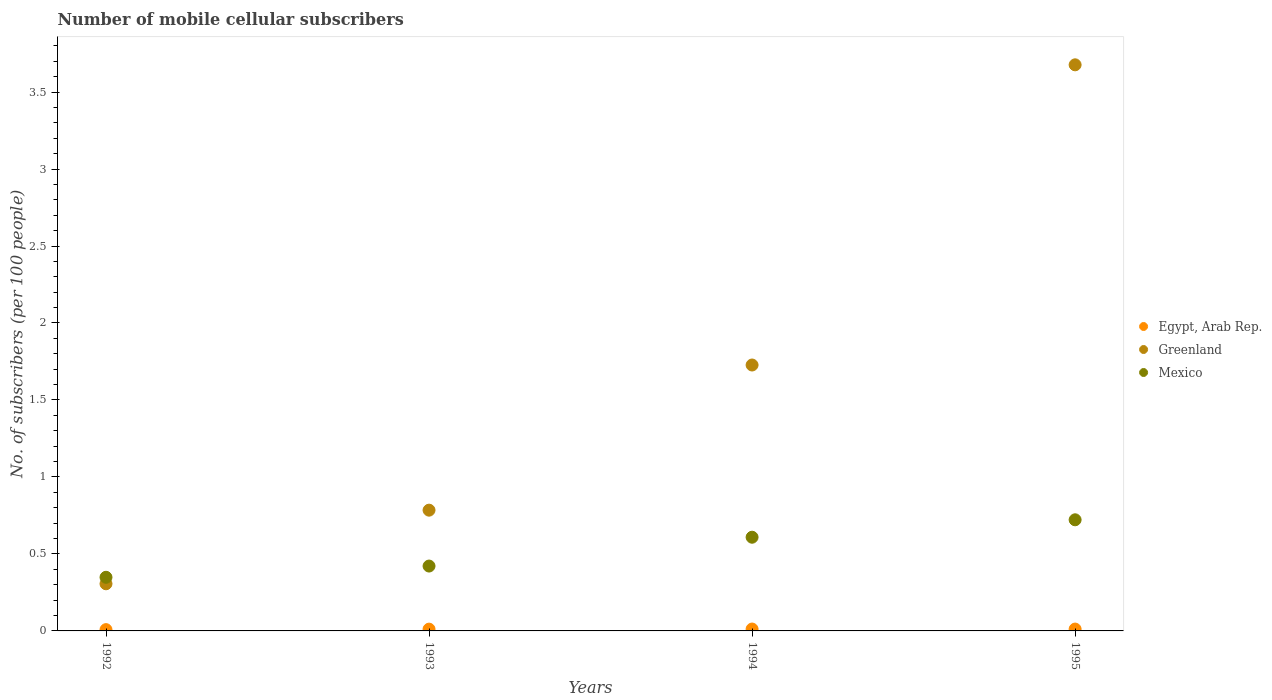How many different coloured dotlines are there?
Your answer should be very brief. 3. Is the number of dotlines equal to the number of legend labels?
Keep it short and to the point. Yes. What is the number of mobile cellular subscribers in Egypt, Arab Rep. in 1993?
Provide a short and direct response. 0.01. Across all years, what is the maximum number of mobile cellular subscribers in Mexico?
Provide a succinct answer. 0.72. Across all years, what is the minimum number of mobile cellular subscribers in Mexico?
Offer a very short reply. 0.35. What is the total number of mobile cellular subscribers in Mexico in the graph?
Provide a succinct answer. 2.1. What is the difference between the number of mobile cellular subscribers in Egypt, Arab Rep. in 1993 and that in 1994?
Give a very brief answer. -0. What is the difference between the number of mobile cellular subscribers in Egypt, Arab Rep. in 1993 and the number of mobile cellular subscribers in Greenland in 1992?
Offer a very short reply. -0.29. What is the average number of mobile cellular subscribers in Mexico per year?
Ensure brevity in your answer.  0.52. In the year 1993, what is the difference between the number of mobile cellular subscribers in Egypt, Arab Rep. and number of mobile cellular subscribers in Greenland?
Give a very brief answer. -0.77. What is the ratio of the number of mobile cellular subscribers in Egypt, Arab Rep. in 1992 to that in 1995?
Provide a short and direct response. 0.7. What is the difference between the highest and the second highest number of mobile cellular subscribers in Greenland?
Your answer should be compact. 1.95. What is the difference between the highest and the lowest number of mobile cellular subscribers in Greenland?
Your answer should be compact. 3.37. In how many years, is the number of mobile cellular subscribers in Mexico greater than the average number of mobile cellular subscribers in Mexico taken over all years?
Keep it short and to the point. 2. Is it the case that in every year, the sum of the number of mobile cellular subscribers in Greenland and number of mobile cellular subscribers in Egypt, Arab Rep.  is greater than the number of mobile cellular subscribers in Mexico?
Offer a very short reply. No. Is the number of mobile cellular subscribers in Greenland strictly greater than the number of mobile cellular subscribers in Mexico over the years?
Your response must be concise. No. Is the number of mobile cellular subscribers in Egypt, Arab Rep. strictly less than the number of mobile cellular subscribers in Greenland over the years?
Offer a terse response. Yes. What is the difference between two consecutive major ticks on the Y-axis?
Offer a very short reply. 0.5. Does the graph contain grids?
Your answer should be very brief. No. Where does the legend appear in the graph?
Your response must be concise. Center right. What is the title of the graph?
Provide a succinct answer. Number of mobile cellular subscribers. What is the label or title of the X-axis?
Provide a succinct answer. Years. What is the label or title of the Y-axis?
Your answer should be compact. No. of subscribers (per 100 people). What is the No. of subscribers (per 100 people) of Egypt, Arab Rep. in 1992?
Your response must be concise. 0.01. What is the No. of subscribers (per 100 people) of Greenland in 1992?
Your answer should be very brief. 0.31. What is the No. of subscribers (per 100 people) in Mexico in 1992?
Offer a terse response. 0.35. What is the No. of subscribers (per 100 people) of Egypt, Arab Rep. in 1993?
Give a very brief answer. 0.01. What is the No. of subscribers (per 100 people) in Greenland in 1993?
Ensure brevity in your answer.  0.78. What is the No. of subscribers (per 100 people) in Mexico in 1993?
Your response must be concise. 0.42. What is the No. of subscribers (per 100 people) of Egypt, Arab Rep. in 1994?
Provide a short and direct response. 0.01. What is the No. of subscribers (per 100 people) in Greenland in 1994?
Give a very brief answer. 1.73. What is the No. of subscribers (per 100 people) of Mexico in 1994?
Your answer should be very brief. 0.61. What is the No. of subscribers (per 100 people) of Egypt, Arab Rep. in 1995?
Your answer should be very brief. 0.01. What is the No. of subscribers (per 100 people) of Greenland in 1995?
Your response must be concise. 3.68. What is the No. of subscribers (per 100 people) of Mexico in 1995?
Keep it short and to the point. 0.72. Across all years, what is the maximum No. of subscribers (per 100 people) of Egypt, Arab Rep.?
Make the answer very short. 0.01. Across all years, what is the maximum No. of subscribers (per 100 people) in Greenland?
Make the answer very short. 3.68. Across all years, what is the maximum No. of subscribers (per 100 people) of Mexico?
Provide a short and direct response. 0.72. Across all years, what is the minimum No. of subscribers (per 100 people) of Egypt, Arab Rep.?
Offer a very short reply. 0.01. Across all years, what is the minimum No. of subscribers (per 100 people) in Greenland?
Ensure brevity in your answer.  0.31. Across all years, what is the minimum No. of subscribers (per 100 people) of Mexico?
Ensure brevity in your answer.  0.35. What is the total No. of subscribers (per 100 people) of Egypt, Arab Rep. in the graph?
Keep it short and to the point. 0.04. What is the total No. of subscribers (per 100 people) of Greenland in the graph?
Your answer should be very brief. 6.49. What is the total No. of subscribers (per 100 people) in Mexico in the graph?
Keep it short and to the point. 2.1. What is the difference between the No. of subscribers (per 100 people) in Egypt, Arab Rep. in 1992 and that in 1993?
Offer a very short reply. -0. What is the difference between the No. of subscribers (per 100 people) in Greenland in 1992 and that in 1993?
Your answer should be compact. -0.48. What is the difference between the No. of subscribers (per 100 people) in Mexico in 1992 and that in 1993?
Make the answer very short. -0.07. What is the difference between the No. of subscribers (per 100 people) of Egypt, Arab Rep. in 1992 and that in 1994?
Your answer should be compact. -0. What is the difference between the No. of subscribers (per 100 people) of Greenland in 1992 and that in 1994?
Your answer should be compact. -1.42. What is the difference between the No. of subscribers (per 100 people) in Mexico in 1992 and that in 1994?
Your response must be concise. -0.26. What is the difference between the No. of subscribers (per 100 people) of Egypt, Arab Rep. in 1992 and that in 1995?
Your answer should be very brief. -0. What is the difference between the No. of subscribers (per 100 people) of Greenland in 1992 and that in 1995?
Provide a short and direct response. -3.37. What is the difference between the No. of subscribers (per 100 people) in Mexico in 1992 and that in 1995?
Your answer should be very brief. -0.37. What is the difference between the No. of subscribers (per 100 people) in Egypt, Arab Rep. in 1993 and that in 1994?
Give a very brief answer. -0. What is the difference between the No. of subscribers (per 100 people) in Greenland in 1993 and that in 1994?
Offer a very short reply. -0.94. What is the difference between the No. of subscribers (per 100 people) in Mexico in 1993 and that in 1994?
Offer a terse response. -0.19. What is the difference between the No. of subscribers (per 100 people) of Egypt, Arab Rep. in 1993 and that in 1995?
Ensure brevity in your answer.  -0. What is the difference between the No. of subscribers (per 100 people) in Greenland in 1993 and that in 1995?
Your answer should be compact. -2.89. What is the difference between the No. of subscribers (per 100 people) in Mexico in 1993 and that in 1995?
Your answer should be very brief. -0.3. What is the difference between the No. of subscribers (per 100 people) in Egypt, Arab Rep. in 1994 and that in 1995?
Ensure brevity in your answer.  0. What is the difference between the No. of subscribers (per 100 people) of Greenland in 1994 and that in 1995?
Offer a very short reply. -1.95. What is the difference between the No. of subscribers (per 100 people) of Mexico in 1994 and that in 1995?
Keep it short and to the point. -0.11. What is the difference between the No. of subscribers (per 100 people) in Egypt, Arab Rep. in 1992 and the No. of subscribers (per 100 people) in Greenland in 1993?
Provide a succinct answer. -0.78. What is the difference between the No. of subscribers (per 100 people) of Egypt, Arab Rep. in 1992 and the No. of subscribers (per 100 people) of Mexico in 1993?
Offer a terse response. -0.41. What is the difference between the No. of subscribers (per 100 people) in Greenland in 1992 and the No. of subscribers (per 100 people) in Mexico in 1993?
Keep it short and to the point. -0.12. What is the difference between the No. of subscribers (per 100 people) of Egypt, Arab Rep. in 1992 and the No. of subscribers (per 100 people) of Greenland in 1994?
Provide a short and direct response. -1.72. What is the difference between the No. of subscribers (per 100 people) of Egypt, Arab Rep. in 1992 and the No. of subscribers (per 100 people) of Mexico in 1994?
Your answer should be compact. -0.6. What is the difference between the No. of subscribers (per 100 people) in Greenland in 1992 and the No. of subscribers (per 100 people) in Mexico in 1994?
Ensure brevity in your answer.  -0.3. What is the difference between the No. of subscribers (per 100 people) in Egypt, Arab Rep. in 1992 and the No. of subscribers (per 100 people) in Greenland in 1995?
Your response must be concise. -3.67. What is the difference between the No. of subscribers (per 100 people) in Egypt, Arab Rep. in 1992 and the No. of subscribers (per 100 people) in Mexico in 1995?
Keep it short and to the point. -0.71. What is the difference between the No. of subscribers (per 100 people) in Greenland in 1992 and the No. of subscribers (per 100 people) in Mexico in 1995?
Provide a succinct answer. -0.42. What is the difference between the No. of subscribers (per 100 people) of Egypt, Arab Rep. in 1993 and the No. of subscribers (per 100 people) of Greenland in 1994?
Provide a short and direct response. -1.72. What is the difference between the No. of subscribers (per 100 people) in Egypt, Arab Rep. in 1993 and the No. of subscribers (per 100 people) in Mexico in 1994?
Your answer should be very brief. -0.6. What is the difference between the No. of subscribers (per 100 people) in Greenland in 1993 and the No. of subscribers (per 100 people) in Mexico in 1994?
Your response must be concise. 0.18. What is the difference between the No. of subscribers (per 100 people) of Egypt, Arab Rep. in 1993 and the No. of subscribers (per 100 people) of Greenland in 1995?
Provide a short and direct response. -3.67. What is the difference between the No. of subscribers (per 100 people) of Egypt, Arab Rep. in 1993 and the No. of subscribers (per 100 people) of Mexico in 1995?
Your response must be concise. -0.71. What is the difference between the No. of subscribers (per 100 people) of Greenland in 1993 and the No. of subscribers (per 100 people) of Mexico in 1995?
Your answer should be very brief. 0.06. What is the difference between the No. of subscribers (per 100 people) in Egypt, Arab Rep. in 1994 and the No. of subscribers (per 100 people) in Greenland in 1995?
Your answer should be very brief. -3.66. What is the difference between the No. of subscribers (per 100 people) in Egypt, Arab Rep. in 1994 and the No. of subscribers (per 100 people) in Mexico in 1995?
Offer a terse response. -0.71. What is the average No. of subscribers (per 100 people) in Egypt, Arab Rep. per year?
Your answer should be compact. 0.01. What is the average No. of subscribers (per 100 people) in Greenland per year?
Keep it short and to the point. 1.62. What is the average No. of subscribers (per 100 people) in Mexico per year?
Your answer should be very brief. 0.53. In the year 1992, what is the difference between the No. of subscribers (per 100 people) of Egypt, Arab Rep. and No. of subscribers (per 100 people) of Greenland?
Offer a terse response. -0.3. In the year 1992, what is the difference between the No. of subscribers (per 100 people) of Egypt, Arab Rep. and No. of subscribers (per 100 people) of Mexico?
Provide a succinct answer. -0.34. In the year 1992, what is the difference between the No. of subscribers (per 100 people) in Greenland and No. of subscribers (per 100 people) in Mexico?
Your answer should be compact. -0.04. In the year 1993, what is the difference between the No. of subscribers (per 100 people) in Egypt, Arab Rep. and No. of subscribers (per 100 people) in Greenland?
Keep it short and to the point. -0.77. In the year 1993, what is the difference between the No. of subscribers (per 100 people) of Egypt, Arab Rep. and No. of subscribers (per 100 people) of Mexico?
Make the answer very short. -0.41. In the year 1993, what is the difference between the No. of subscribers (per 100 people) in Greenland and No. of subscribers (per 100 people) in Mexico?
Give a very brief answer. 0.36. In the year 1994, what is the difference between the No. of subscribers (per 100 people) in Egypt, Arab Rep. and No. of subscribers (per 100 people) in Greenland?
Keep it short and to the point. -1.71. In the year 1994, what is the difference between the No. of subscribers (per 100 people) in Egypt, Arab Rep. and No. of subscribers (per 100 people) in Mexico?
Offer a terse response. -0.6. In the year 1994, what is the difference between the No. of subscribers (per 100 people) of Greenland and No. of subscribers (per 100 people) of Mexico?
Make the answer very short. 1.12. In the year 1995, what is the difference between the No. of subscribers (per 100 people) of Egypt, Arab Rep. and No. of subscribers (per 100 people) of Greenland?
Make the answer very short. -3.66. In the year 1995, what is the difference between the No. of subscribers (per 100 people) of Egypt, Arab Rep. and No. of subscribers (per 100 people) of Mexico?
Your response must be concise. -0.71. In the year 1995, what is the difference between the No. of subscribers (per 100 people) of Greenland and No. of subscribers (per 100 people) of Mexico?
Keep it short and to the point. 2.96. What is the ratio of the No. of subscribers (per 100 people) in Egypt, Arab Rep. in 1992 to that in 1993?
Provide a succinct answer. 0.73. What is the ratio of the No. of subscribers (per 100 people) of Greenland in 1992 to that in 1993?
Provide a short and direct response. 0.39. What is the ratio of the No. of subscribers (per 100 people) of Mexico in 1992 to that in 1993?
Make the answer very short. 0.83. What is the ratio of the No. of subscribers (per 100 people) in Egypt, Arab Rep. in 1992 to that in 1994?
Keep it short and to the point. 0.69. What is the ratio of the No. of subscribers (per 100 people) of Greenland in 1992 to that in 1994?
Your response must be concise. 0.18. What is the ratio of the No. of subscribers (per 100 people) of Mexico in 1992 to that in 1994?
Your answer should be very brief. 0.57. What is the ratio of the No. of subscribers (per 100 people) in Egypt, Arab Rep. in 1992 to that in 1995?
Your answer should be compact. 0.7. What is the ratio of the No. of subscribers (per 100 people) in Greenland in 1992 to that in 1995?
Your response must be concise. 0.08. What is the ratio of the No. of subscribers (per 100 people) of Mexico in 1992 to that in 1995?
Your answer should be very brief. 0.48. What is the ratio of the No. of subscribers (per 100 people) of Egypt, Arab Rep. in 1993 to that in 1994?
Provide a short and direct response. 0.95. What is the ratio of the No. of subscribers (per 100 people) in Greenland in 1993 to that in 1994?
Provide a short and direct response. 0.45. What is the ratio of the No. of subscribers (per 100 people) in Mexico in 1993 to that in 1994?
Your answer should be very brief. 0.69. What is the ratio of the No. of subscribers (per 100 people) of Egypt, Arab Rep. in 1993 to that in 1995?
Offer a very short reply. 0.96. What is the ratio of the No. of subscribers (per 100 people) in Greenland in 1993 to that in 1995?
Give a very brief answer. 0.21. What is the ratio of the No. of subscribers (per 100 people) of Mexico in 1993 to that in 1995?
Your answer should be compact. 0.58. What is the ratio of the No. of subscribers (per 100 people) in Greenland in 1994 to that in 1995?
Provide a succinct answer. 0.47. What is the ratio of the No. of subscribers (per 100 people) in Mexico in 1994 to that in 1995?
Offer a very short reply. 0.84. What is the difference between the highest and the second highest No. of subscribers (per 100 people) of Greenland?
Your answer should be very brief. 1.95. What is the difference between the highest and the second highest No. of subscribers (per 100 people) in Mexico?
Offer a terse response. 0.11. What is the difference between the highest and the lowest No. of subscribers (per 100 people) in Egypt, Arab Rep.?
Ensure brevity in your answer.  0. What is the difference between the highest and the lowest No. of subscribers (per 100 people) in Greenland?
Your answer should be very brief. 3.37. What is the difference between the highest and the lowest No. of subscribers (per 100 people) in Mexico?
Ensure brevity in your answer.  0.37. 